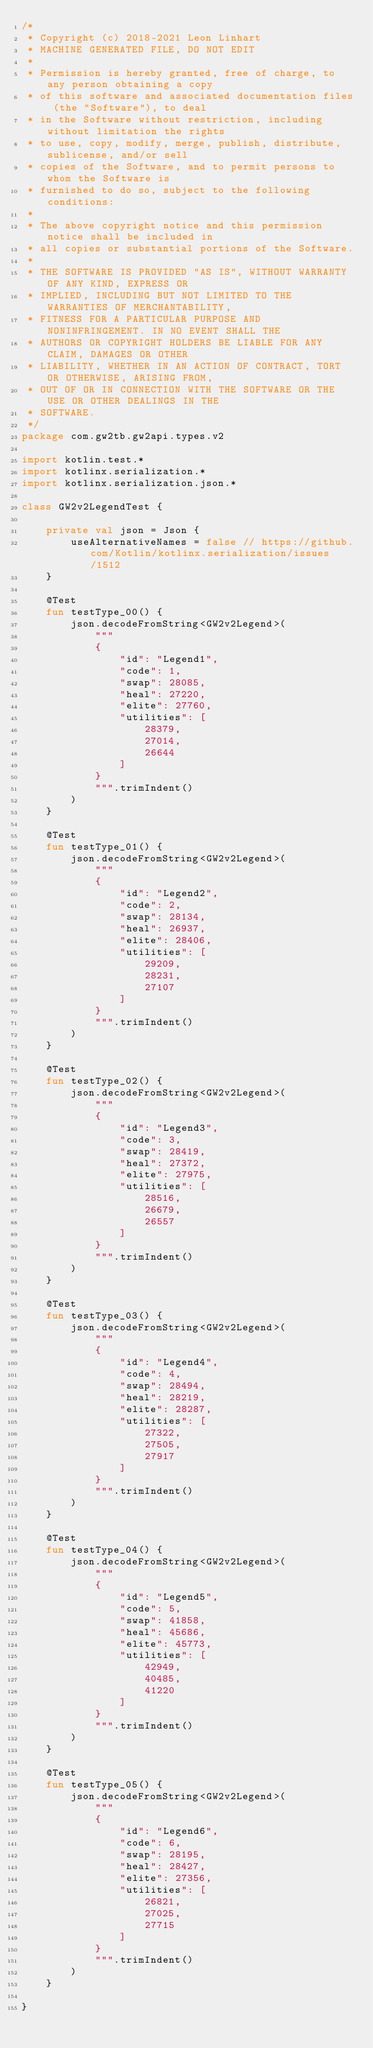Convert code to text. <code><loc_0><loc_0><loc_500><loc_500><_Kotlin_>/*
 * Copyright (c) 2018-2021 Leon Linhart
 * MACHINE GENERATED FILE, DO NOT EDIT
 *
 * Permission is hereby granted, free of charge, to any person obtaining a copy
 * of this software and associated documentation files (the "Software"), to deal
 * in the Software without restriction, including without limitation the rights
 * to use, copy, modify, merge, publish, distribute, sublicense, and/or sell
 * copies of the Software, and to permit persons to whom the Software is
 * furnished to do so, subject to the following conditions:
 *
 * The above copyright notice and this permission notice shall be included in
 * all copies or substantial portions of the Software.
 *
 * THE SOFTWARE IS PROVIDED "AS IS", WITHOUT WARRANTY OF ANY KIND, EXPRESS OR
 * IMPLIED, INCLUDING BUT NOT LIMITED TO THE WARRANTIES OF MERCHANTABILITY,
 * FITNESS FOR A PARTICULAR PURPOSE AND NONINFRINGEMENT. IN NO EVENT SHALL THE
 * AUTHORS OR COPYRIGHT HOLDERS BE LIABLE FOR ANY CLAIM, DAMAGES OR OTHER
 * LIABILITY, WHETHER IN AN ACTION OF CONTRACT, TORT OR OTHERWISE, ARISING FROM,
 * OUT OF OR IN CONNECTION WITH THE SOFTWARE OR THE USE OR OTHER DEALINGS IN THE
 * SOFTWARE.
 */
package com.gw2tb.gw2api.types.v2

import kotlin.test.*
import kotlinx.serialization.*
import kotlinx.serialization.json.*

class GW2v2LegendTest {

    private val json = Json {
        useAlternativeNames = false // https://github.com/Kotlin/kotlinx.serialization/issues/1512
    }

    @Test
    fun testType_00() {
        json.decodeFromString<GW2v2Legend>(
            """
            {
                "id": "Legend1",
                "code": 1,
                "swap": 28085,
                "heal": 27220,
                "elite": 27760,
                "utilities": [
                    28379,
                    27014,
                    26644
                ]
            }
            """.trimIndent()
        )
    }
    
    @Test
    fun testType_01() {
        json.decodeFromString<GW2v2Legend>(
            """
            {
                "id": "Legend2",
                "code": 2,
                "swap": 28134,
                "heal": 26937,
                "elite": 28406,
                "utilities": [
                    29209,
                    28231,
                    27107
                ]
            }
            """.trimIndent()
        )
    }
    
    @Test
    fun testType_02() {
        json.decodeFromString<GW2v2Legend>(
            """
            {
                "id": "Legend3",
                "code": 3,
                "swap": 28419,
                "heal": 27372,
                "elite": 27975,
                "utilities": [
                    28516,
                    26679,
                    26557
                ]
            }
            """.trimIndent()
        )
    }
    
    @Test
    fun testType_03() {
        json.decodeFromString<GW2v2Legend>(
            """
            {
                "id": "Legend4",
                "code": 4,
                "swap": 28494,
                "heal": 28219,
                "elite": 28287,
                "utilities": [
                    27322,
                    27505,
                    27917
                ]
            }
            """.trimIndent()
        )
    }
    
    @Test
    fun testType_04() {
        json.decodeFromString<GW2v2Legend>(
            """
            {
                "id": "Legend5",
                "code": 5,
                "swap": 41858,
                "heal": 45686,
                "elite": 45773,
                "utilities": [
                    42949,
                    40485,
                    41220
                ]
            }
            """.trimIndent()
        )
    }
    
    @Test
    fun testType_05() {
        json.decodeFromString<GW2v2Legend>(
            """
            {
                "id": "Legend6",
                "code": 6,
                "swap": 28195,
                "heal": 28427,
                "elite": 27356,
                "utilities": [
                    26821,
                    27025,
                    27715
                ]
            }
            """.trimIndent()
        )
    }

}</code> 